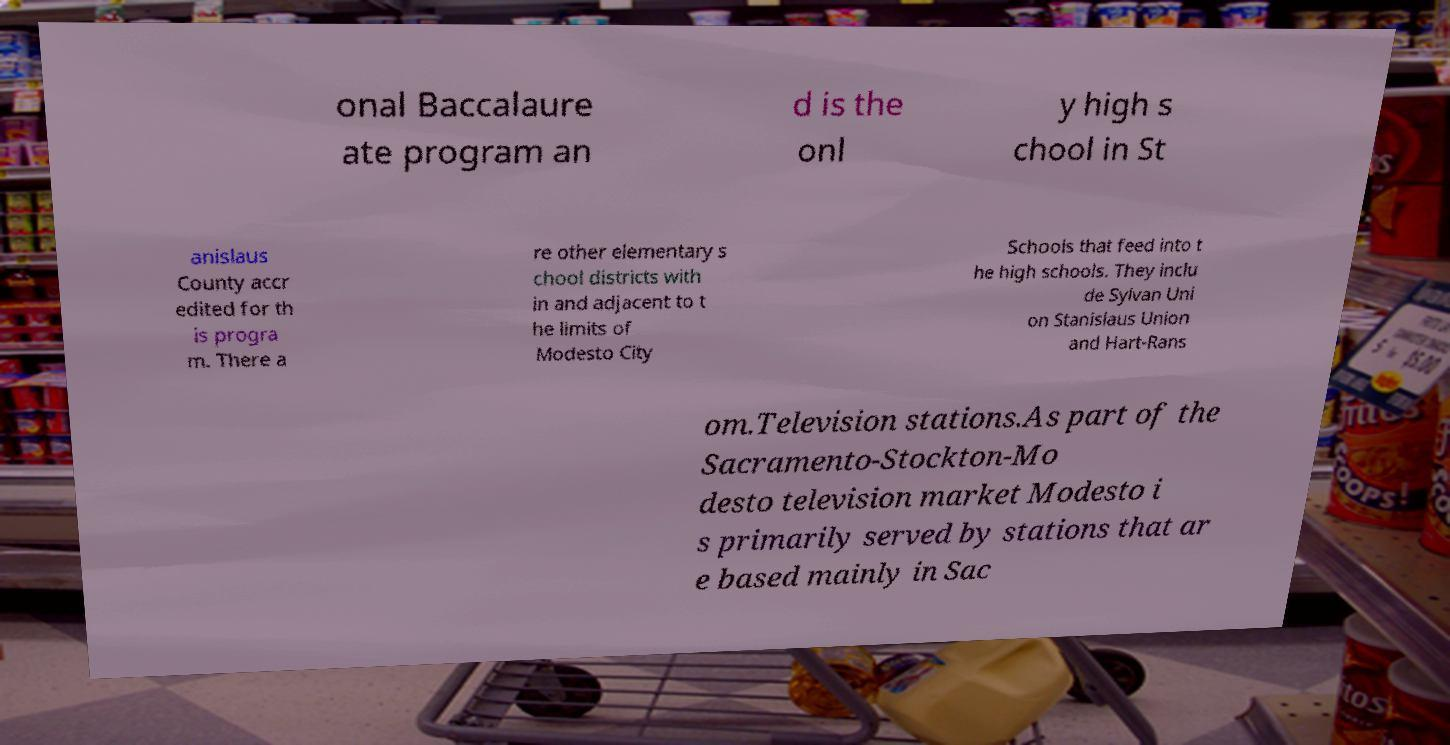I need the written content from this picture converted into text. Can you do that? onal Baccalaure ate program an d is the onl y high s chool in St anislaus County accr edited for th is progra m. There a re other elementary s chool districts with in and adjacent to t he limits of Modesto City Schools that feed into t he high schools. They inclu de Sylvan Uni on Stanislaus Union and Hart-Rans om.Television stations.As part of the Sacramento-Stockton-Mo desto television market Modesto i s primarily served by stations that ar e based mainly in Sac 